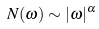Convert formula to latex. <formula><loc_0><loc_0><loc_500><loc_500>N ( \omega ) \sim | \omega | ^ { \alpha }</formula> 